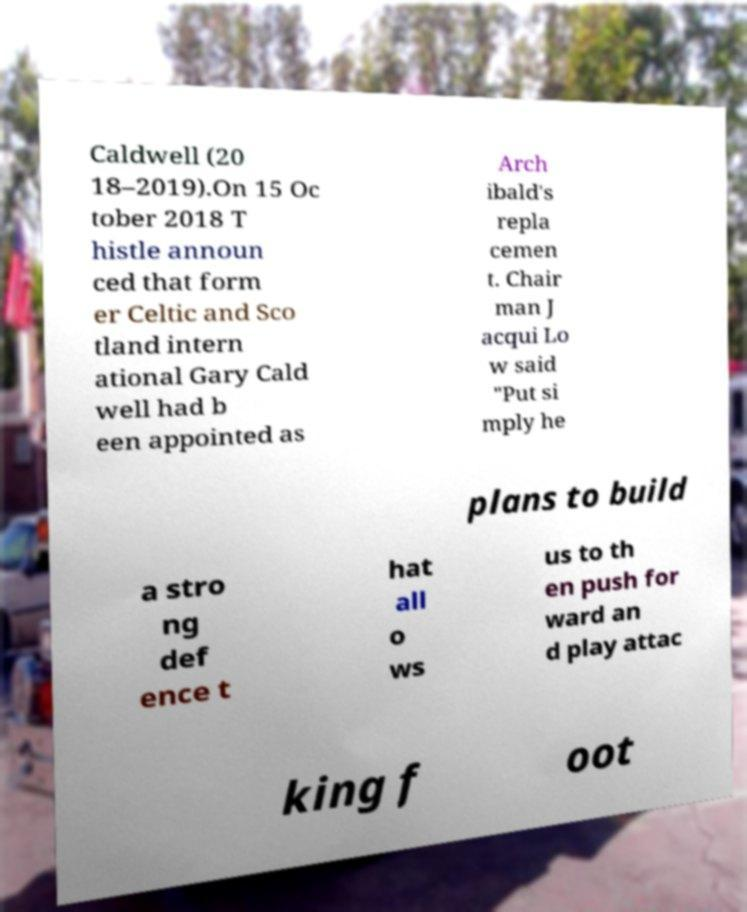What messages or text are displayed in this image? I need them in a readable, typed format. Caldwell (20 18–2019).On 15 Oc tober 2018 T histle announ ced that form er Celtic and Sco tland intern ational Gary Cald well had b een appointed as Arch ibald's repla cemen t. Chair man J acqui Lo w said "Put si mply he plans to build a stro ng def ence t hat all o ws us to th en push for ward an d play attac king f oot 